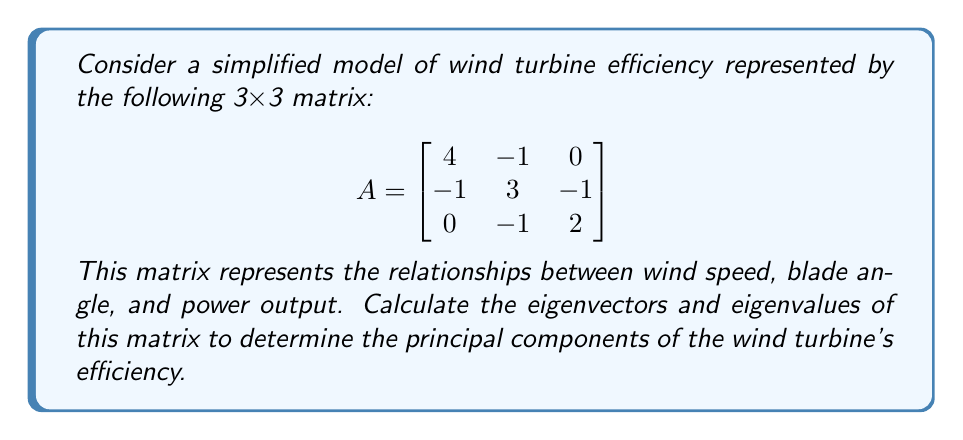Can you answer this question? To find the eigenvectors and eigenvalues of matrix A, we follow these steps:

1) First, we need to find the characteristic equation:
   $det(A - \lambda I) = 0$

   $$\begin{vmatrix}
   4-\lambda & -1 & 0 \\
   -1 & 3-\lambda & -1 \\
   0 & -1 & 2-\lambda
   \end{vmatrix} = 0$$

2) Expanding the determinant:
   $(4-\lambda)[(3-\lambda)(2-\lambda) - 1] + (-1)[(-1)(2-\lambda) - 0] = 0$
   
   $(4-\lambda)(6-5\lambda+\lambda^2 - 1) + (2-\lambda) = 0$
   
   $(4-\lambda)(5-5\lambda+\lambda^2) + (2-\lambda) = 0$
   
   $20-20\lambda+4\lambda^2-5\lambda+5\lambda^2-\lambda^3+2-\lambda = 0$
   
   $-\lambda^3+9\lambda^2-26\lambda+22 = 0$

3) Solving this cubic equation (you can use the cubic formula or a numerical method), we get:
   $\lambda_1 = 5$, $\lambda_2 = 3$, $\lambda_3 = 1$

4) Now, for each eigenvalue, we find the corresponding eigenvector by solving $(A - \lambda I)\vec{v} = \vec{0}$

   For $\lambda_1 = 5$:
   $$\begin{bmatrix}
   -1 & -1 & 0 \\
   -1 & -2 & -1 \\
   0 & -1 & -3
   \end{bmatrix}\begin{bmatrix}
   v_1 \\
   v_2 \\
   v_3
   \end{bmatrix} = \begin{bmatrix}
   0 \\
   0 \\
   0
   \end{bmatrix}$$

   Solving this, we get: $\vec{v_1} = (1, 1, 1)$

   For $\lambda_2 = 3$:
   $$\begin{bmatrix}
   1 & -1 & 0 \\
   -1 & 0 & -1 \\
   0 & -1 & -1
   \end{bmatrix}\begin{bmatrix}
   v_1 \\
   v_2 \\
   v_3
   \end{bmatrix} = \begin{bmatrix}
   0 \\
   0 \\
   0
   \end{bmatrix}$$

   Solving this, we get: $\vec{v_2} = (1, 2, 1)$

   For $\lambda_3 = 1$:
   $$\begin{bmatrix}
   3 & -1 & 0 \\
   -1 & 2 & -1 \\
   0 & -1 & 1
   \end{bmatrix}\begin{bmatrix}
   v_1 \\
   v_2 \\
   v_3
   \end{bmatrix} = \begin{bmatrix}
   0 \\
   0 \\
   0
   \end{bmatrix}$$

   Solving this, we get: $\vec{v_3} = (1, 3, 3)$

5) Normalize the eigenvectors:
   $\vec{v_1} = (\frac{1}{\sqrt{3}}, \frac{1}{\sqrt{3}}, \frac{1}{\sqrt{3}})$
   $\vec{v_2} = (\frac{1}{\sqrt{6}}, \frac{2}{\sqrt{6}}, \frac{1}{\sqrt{6}})$
   $\vec{v_3} = (\frac{1}{\sqrt{19}}, \frac{3}{\sqrt{19}}, \frac{3}{\sqrt{19}})$
Answer: Eigenvalues: $\lambda_1 = 5$, $\lambda_2 = 3$, $\lambda_3 = 1$

Normalized eigenvectors:
$\vec{v_1} = (\frac{1}{\sqrt{3}}, \frac{1}{\sqrt{3}}, \frac{1}{\sqrt{3}})$
$\vec{v_2} = (\frac{1}{\sqrt{6}}, \frac{2}{\sqrt{6}}, \frac{1}{\sqrt{6}})$
$\vec{v_3} = (\frac{1}{\sqrt{19}}, \frac{3}{\sqrt{19}}, \frac{3}{\sqrt{19}})$ 